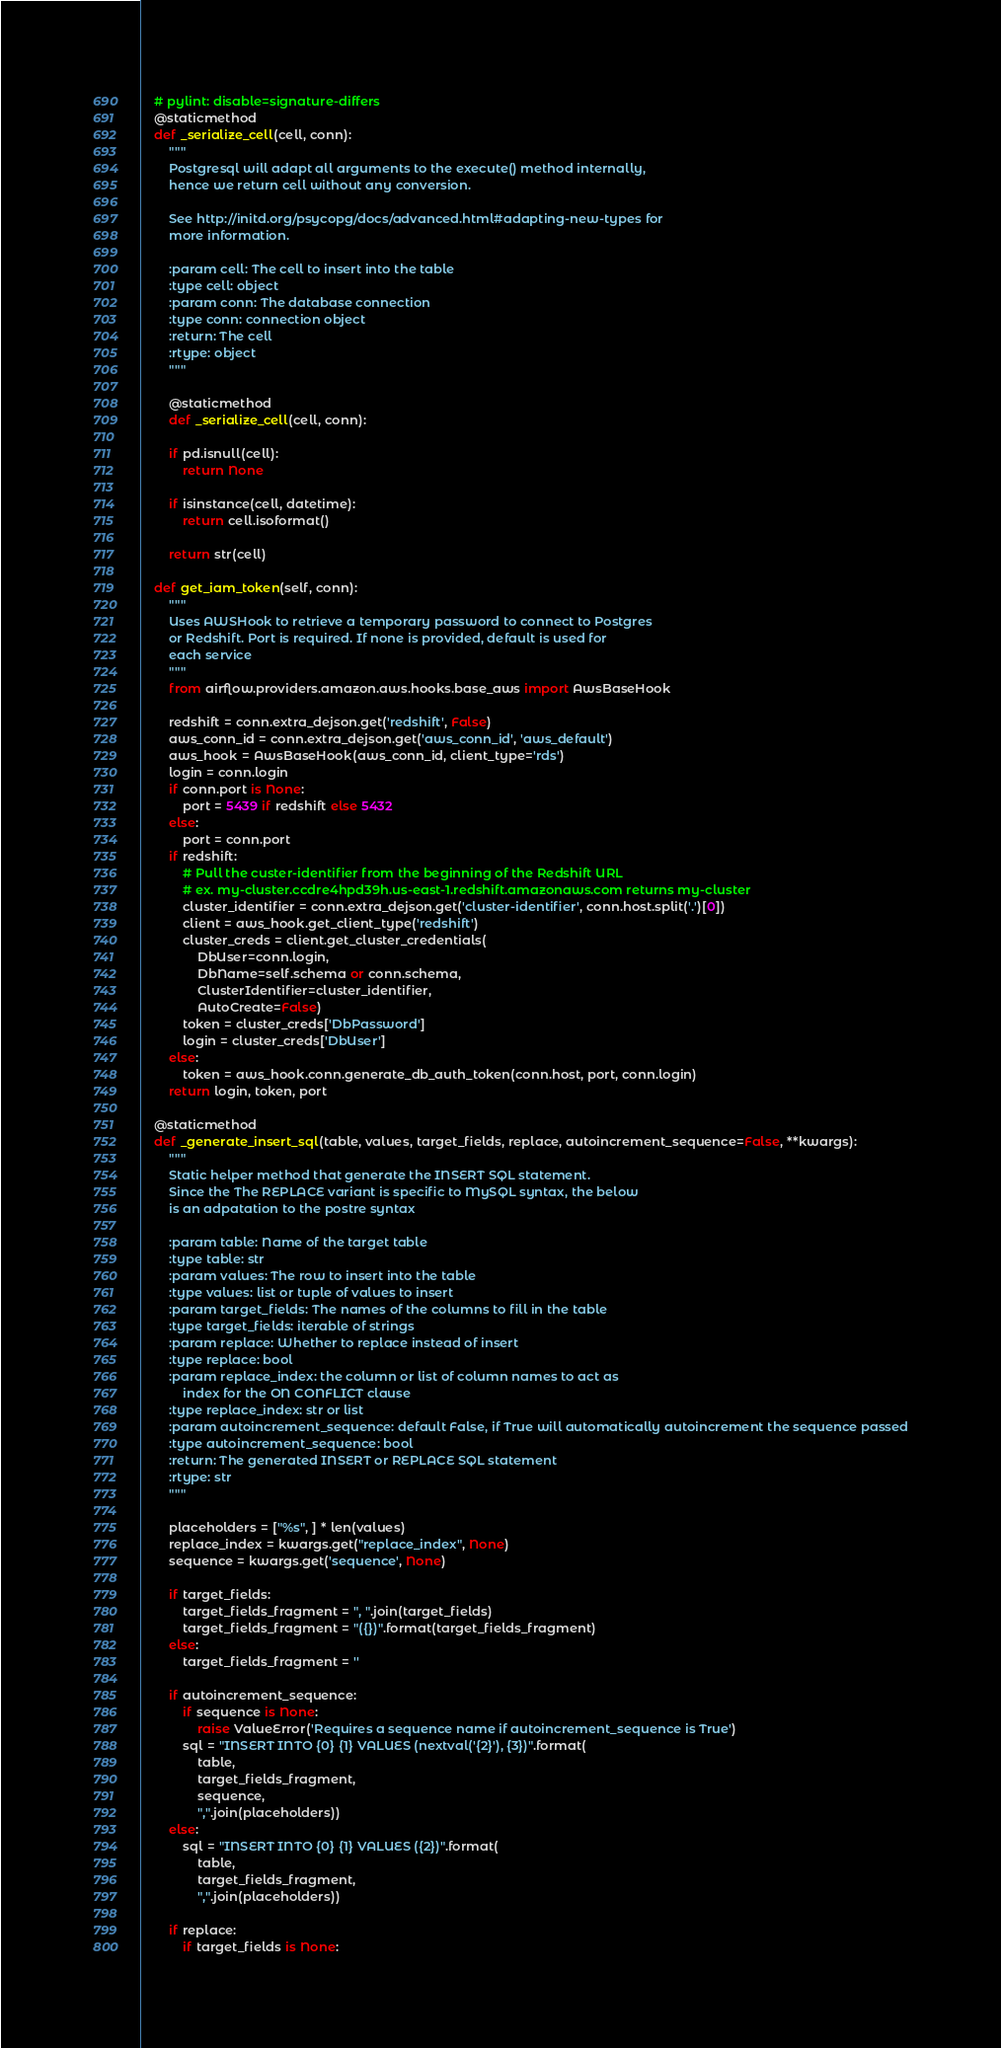<code> <loc_0><loc_0><loc_500><loc_500><_Python_>
    # pylint: disable=signature-differs
    @staticmethod
    def _serialize_cell(cell, conn):
        """
        Postgresql will adapt all arguments to the execute() method internally,
        hence we return cell without any conversion.
    
        See http://initd.org/psycopg/docs/advanced.html#adapting-new-types for
        more information.

        :param cell: The cell to insert into the table
        :type cell: object
        :param conn: The database connection
        :type conn: connection object
        :return: The cell
        :rtype: object
        """
 
        @staticmethod
        def _serialize_cell(cell, conn):

        if pd.isnull(cell):
            return None

        if isinstance(cell, datetime):
            return cell.isoformat()
  
        return str(cell)

    def get_iam_token(self, conn):
        """
        Uses AWSHook to retrieve a temporary password to connect to Postgres
        or Redshift. Port is required. If none is provided, default is used for
        each service
        """
        from airflow.providers.amazon.aws.hooks.base_aws import AwsBaseHook

        redshift = conn.extra_dejson.get('redshift', False)
        aws_conn_id = conn.extra_dejson.get('aws_conn_id', 'aws_default')
        aws_hook = AwsBaseHook(aws_conn_id, client_type='rds')
        login = conn.login
        if conn.port is None:
            port = 5439 if redshift else 5432
        else:
            port = conn.port
        if redshift:
            # Pull the custer-identifier from the beginning of the Redshift URL
            # ex. my-cluster.ccdre4hpd39h.us-east-1.redshift.amazonaws.com returns my-cluster
            cluster_identifier = conn.extra_dejson.get('cluster-identifier', conn.host.split('.')[0])
            client = aws_hook.get_client_type('redshift')
            cluster_creds = client.get_cluster_credentials(
                DbUser=conn.login,
                DbName=self.schema or conn.schema,
                ClusterIdentifier=cluster_identifier,
                AutoCreate=False)
            token = cluster_creds['DbPassword']
            login = cluster_creds['DbUser']
        else:
            token = aws_hook.conn.generate_db_auth_token(conn.host, port, conn.login)
        return login, token, port

    @staticmethod
    def _generate_insert_sql(table, values, target_fields, replace, autoincrement_sequence=False, **kwargs):
        """
        Static helper method that generate the INSERT SQL statement.
        Since the The REPLACE variant is specific to MySQL syntax, the below
        is an adpatation to the postre syntax

        :param table: Name of the target table
        :type table: str
        :param values: The row to insert into the table
        :type values: list or tuple of values to insert
        :param target_fields: The names of the columns to fill in the table
        :type target_fields: iterable of strings
        :param replace: Whether to replace instead of insert
        :type replace: bool
        :param replace_index: the column or list of column names to act as
            index for the ON CONFLICT clause
        :type replace_index: str or list
        :param autoincrement_sequence: default False, if True will automatically autoincrement the sequence passed
        :type autoincrement_sequence: bool
        :return: The generated INSERT or REPLACE SQL statement
        :rtype: str
        """

        placeholders = ["%s", ] * len(values)
        replace_index = kwargs.get("replace_index", None)
        sequence = kwargs.get('sequence', None)

        if target_fields:
            target_fields_fragment = ", ".join(target_fields)
            target_fields_fragment = "({})".format(target_fields_fragment)
        else:
            target_fields_fragment = ''

        if autoincrement_sequence:
            if sequence is None:
                raise ValueError('Requires a sequence name if autoincrement_sequence is True')
            sql = "INSERT INTO {0} {1} VALUES (nextval('{2}'), {3})".format(
                table,
                target_fields_fragment,
                sequence,
                ",".join(placeholders))
        else:
            sql = "INSERT INTO {0} {1} VALUES ({2})".format(
                table,
                target_fields_fragment,
                ",".join(placeholders))

        if replace:
            if target_fields is None:</code> 